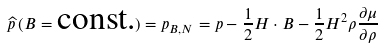<formula> <loc_0><loc_0><loc_500><loc_500>\widehat { p } \, ( B = \text {const.} ) = p _ { B , N } = p - \frac { 1 } { 2 } H \cdot B - \frac { 1 } { 2 } H ^ { 2 } \rho \frac { \partial \mu } { \partial \rho }</formula> 